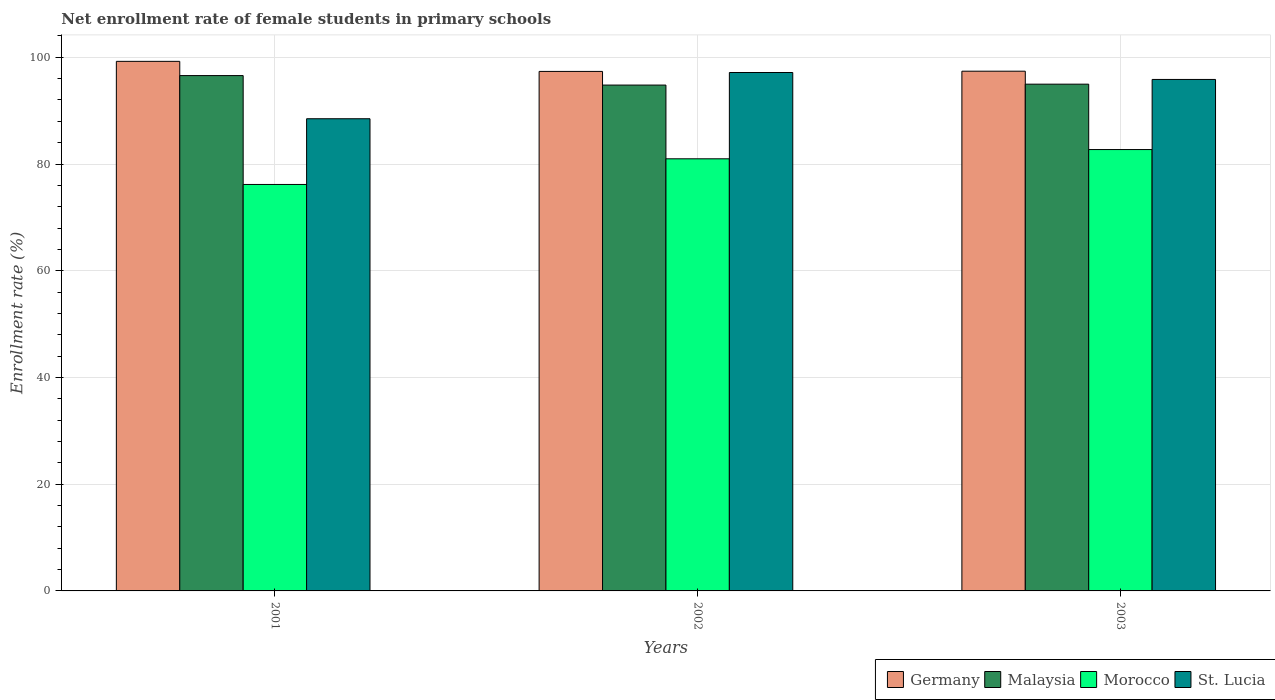How many different coloured bars are there?
Ensure brevity in your answer.  4. How many groups of bars are there?
Offer a very short reply. 3. Are the number of bars per tick equal to the number of legend labels?
Provide a succinct answer. Yes. Are the number of bars on each tick of the X-axis equal?
Your answer should be compact. Yes. What is the net enrollment rate of female students in primary schools in St. Lucia in 2003?
Your response must be concise. 95.85. Across all years, what is the maximum net enrollment rate of female students in primary schools in St. Lucia?
Provide a succinct answer. 97.15. Across all years, what is the minimum net enrollment rate of female students in primary schools in Malaysia?
Offer a terse response. 94.8. In which year was the net enrollment rate of female students in primary schools in Morocco maximum?
Your response must be concise. 2003. What is the total net enrollment rate of female students in primary schools in St. Lucia in the graph?
Offer a terse response. 281.49. What is the difference between the net enrollment rate of female students in primary schools in Malaysia in 2002 and that in 2003?
Offer a terse response. -0.17. What is the difference between the net enrollment rate of female students in primary schools in Germany in 2003 and the net enrollment rate of female students in primary schools in St. Lucia in 2001?
Offer a terse response. 8.91. What is the average net enrollment rate of female students in primary schools in Germany per year?
Offer a terse response. 98. In the year 2001, what is the difference between the net enrollment rate of female students in primary schools in Morocco and net enrollment rate of female students in primary schools in Malaysia?
Offer a very short reply. -20.4. In how many years, is the net enrollment rate of female students in primary schools in Morocco greater than 28 %?
Your answer should be very brief. 3. What is the ratio of the net enrollment rate of female students in primary schools in St. Lucia in 2002 to that in 2003?
Your response must be concise. 1.01. Is the difference between the net enrollment rate of female students in primary schools in Morocco in 2002 and 2003 greater than the difference between the net enrollment rate of female students in primary schools in Malaysia in 2002 and 2003?
Provide a succinct answer. No. What is the difference between the highest and the second highest net enrollment rate of female students in primary schools in Germany?
Offer a very short reply. 1.84. What is the difference between the highest and the lowest net enrollment rate of female students in primary schools in Germany?
Offer a terse response. 1.89. In how many years, is the net enrollment rate of female students in primary schools in Morocco greater than the average net enrollment rate of female students in primary schools in Morocco taken over all years?
Ensure brevity in your answer.  2. What does the 2nd bar from the left in 2003 represents?
Your response must be concise. Malaysia. What does the 2nd bar from the right in 2001 represents?
Keep it short and to the point. Morocco. Is it the case that in every year, the sum of the net enrollment rate of female students in primary schools in Malaysia and net enrollment rate of female students in primary schools in Germany is greater than the net enrollment rate of female students in primary schools in Morocco?
Provide a short and direct response. Yes. How many bars are there?
Offer a terse response. 12. Are all the bars in the graph horizontal?
Your answer should be very brief. No. Are the values on the major ticks of Y-axis written in scientific E-notation?
Offer a very short reply. No. Does the graph contain any zero values?
Ensure brevity in your answer.  No. Where does the legend appear in the graph?
Give a very brief answer. Bottom right. How many legend labels are there?
Offer a very short reply. 4. How are the legend labels stacked?
Give a very brief answer. Horizontal. What is the title of the graph?
Ensure brevity in your answer.  Net enrollment rate of female students in primary schools. What is the label or title of the Y-axis?
Your answer should be very brief. Enrollment rate (%). What is the Enrollment rate (%) in Germany in 2001?
Offer a terse response. 99.24. What is the Enrollment rate (%) of Malaysia in 2001?
Provide a succinct answer. 96.57. What is the Enrollment rate (%) in Morocco in 2001?
Ensure brevity in your answer.  76.17. What is the Enrollment rate (%) of St. Lucia in 2001?
Offer a terse response. 88.49. What is the Enrollment rate (%) in Germany in 2002?
Your answer should be compact. 97.36. What is the Enrollment rate (%) of Malaysia in 2002?
Your response must be concise. 94.8. What is the Enrollment rate (%) of Morocco in 2002?
Offer a very short reply. 80.98. What is the Enrollment rate (%) of St. Lucia in 2002?
Offer a very short reply. 97.15. What is the Enrollment rate (%) in Germany in 2003?
Give a very brief answer. 97.4. What is the Enrollment rate (%) of Malaysia in 2003?
Keep it short and to the point. 94.97. What is the Enrollment rate (%) of Morocco in 2003?
Offer a terse response. 82.71. What is the Enrollment rate (%) of St. Lucia in 2003?
Your response must be concise. 95.85. Across all years, what is the maximum Enrollment rate (%) in Germany?
Make the answer very short. 99.24. Across all years, what is the maximum Enrollment rate (%) of Malaysia?
Provide a short and direct response. 96.57. Across all years, what is the maximum Enrollment rate (%) in Morocco?
Ensure brevity in your answer.  82.71. Across all years, what is the maximum Enrollment rate (%) in St. Lucia?
Provide a succinct answer. 97.15. Across all years, what is the minimum Enrollment rate (%) in Germany?
Provide a succinct answer. 97.36. Across all years, what is the minimum Enrollment rate (%) of Malaysia?
Give a very brief answer. 94.8. Across all years, what is the minimum Enrollment rate (%) of Morocco?
Ensure brevity in your answer.  76.17. Across all years, what is the minimum Enrollment rate (%) of St. Lucia?
Your response must be concise. 88.49. What is the total Enrollment rate (%) of Germany in the graph?
Make the answer very short. 293.99. What is the total Enrollment rate (%) in Malaysia in the graph?
Your answer should be compact. 286.34. What is the total Enrollment rate (%) of Morocco in the graph?
Your answer should be compact. 239.86. What is the total Enrollment rate (%) of St. Lucia in the graph?
Your response must be concise. 281.49. What is the difference between the Enrollment rate (%) of Germany in 2001 and that in 2002?
Make the answer very short. 1.89. What is the difference between the Enrollment rate (%) of Malaysia in 2001 and that in 2002?
Make the answer very short. 1.78. What is the difference between the Enrollment rate (%) of Morocco in 2001 and that in 2002?
Your answer should be very brief. -4.81. What is the difference between the Enrollment rate (%) in St. Lucia in 2001 and that in 2002?
Your answer should be compact. -8.66. What is the difference between the Enrollment rate (%) in Germany in 2001 and that in 2003?
Ensure brevity in your answer.  1.84. What is the difference between the Enrollment rate (%) in Malaysia in 2001 and that in 2003?
Offer a very short reply. 1.61. What is the difference between the Enrollment rate (%) of Morocco in 2001 and that in 2003?
Offer a terse response. -6.54. What is the difference between the Enrollment rate (%) in St. Lucia in 2001 and that in 2003?
Offer a terse response. -7.36. What is the difference between the Enrollment rate (%) in Germany in 2002 and that in 2003?
Keep it short and to the point. -0.04. What is the difference between the Enrollment rate (%) of Malaysia in 2002 and that in 2003?
Offer a very short reply. -0.17. What is the difference between the Enrollment rate (%) of Morocco in 2002 and that in 2003?
Your answer should be very brief. -1.73. What is the difference between the Enrollment rate (%) of St. Lucia in 2002 and that in 2003?
Provide a short and direct response. 1.3. What is the difference between the Enrollment rate (%) in Germany in 2001 and the Enrollment rate (%) in Malaysia in 2002?
Offer a very short reply. 4.44. What is the difference between the Enrollment rate (%) in Germany in 2001 and the Enrollment rate (%) in Morocco in 2002?
Offer a very short reply. 18.26. What is the difference between the Enrollment rate (%) of Germany in 2001 and the Enrollment rate (%) of St. Lucia in 2002?
Provide a succinct answer. 2.09. What is the difference between the Enrollment rate (%) of Malaysia in 2001 and the Enrollment rate (%) of Morocco in 2002?
Your response must be concise. 15.6. What is the difference between the Enrollment rate (%) in Malaysia in 2001 and the Enrollment rate (%) in St. Lucia in 2002?
Give a very brief answer. -0.58. What is the difference between the Enrollment rate (%) in Morocco in 2001 and the Enrollment rate (%) in St. Lucia in 2002?
Your answer should be very brief. -20.98. What is the difference between the Enrollment rate (%) of Germany in 2001 and the Enrollment rate (%) of Malaysia in 2003?
Give a very brief answer. 4.28. What is the difference between the Enrollment rate (%) in Germany in 2001 and the Enrollment rate (%) in Morocco in 2003?
Offer a very short reply. 16.53. What is the difference between the Enrollment rate (%) in Germany in 2001 and the Enrollment rate (%) in St. Lucia in 2003?
Your answer should be compact. 3.39. What is the difference between the Enrollment rate (%) in Malaysia in 2001 and the Enrollment rate (%) in Morocco in 2003?
Give a very brief answer. 13.86. What is the difference between the Enrollment rate (%) of Malaysia in 2001 and the Enrollment rate (%) of St. Lucia in 2003?
Keep it short and to the point. 0.73. What is the difference between the Enrollment rate (%) in Morocco in 2001 and the Enrollment rate (%) in St. Lucia in 2003?
Your answer should be compact. -19.68. What is the difference between the Enrollment rate (%) of Germany in 2002 and the Enrollment rate (%) of Malaysia in 2003?
Give a very brief answer. 2.39. What is the difference between the Enrollment rate (%) of Germany in 2002 and the Enrollment rate (%) of Morocco in 2003?
Provide a succinct answer. 14.64. What is the difference between the Enrollment rate (%) of Germany in 2002 and the Enrollment rate (%) of St. Lucia in 2003?
Your response must be concise. 1.51. What is the difference between the Enrollment rate (%) of Malaysia in 2002 and the Enrollment rate (%) of Morocco in 2003?
Your answer should be compact. 12.09. What is the difference between the Enrollment rate (%) of Malaysia in 2002 and the Enrollment rate (%) of St. Lucia in 2003?
Give a very brief answer. -1.05. What is the difference between the Enrollment rate (%) of Morocco in 2002 and the Enrollment rate (%) of St. Lucia in 2003?
Your answer should be very brief. -14.87. What is the average Enrollment rate (%) in Germany per year?
Keep it short and to the point. 98. What is the average Enrollment rate (%) of Malaysia per year?
Provide a succinct answer. 95.45. What is the average Enrollment rate (%) in Morocco per year?
Offer a very short reply. 79.95. What is the average Enrollment rate (%) of St. Lucia per year?
Offer a very short reply. 93.83. In the year 2001, what is the difference between the Enrollment rate (%) in Germany and Enrollment rate (%) in Malaysia?
Offer a very short reply. 2.67. In the year 2001, what is the difference between the Enrollment rate (%) in Germany and Enrollment rate (%) in Morocco?
Provide a short and direct response. 23.07. In the year 2001, what is the difference between the Enrollment rate (%) in Germany and Enrollment rate (%) in St. Lucia?
Provide a succinct answer. 10.75. In the year 2001, what is the difference between the Enrollment rate (%) of Malaysia and Enrollment rate (%) of Morocco?
Your answer should be very brief. 20.4. In the year 2001, what is the difference between the Enrollment rate (%) of Malaysia and Enrollment rate (%) of St. Lucia?
Provide a succinct answer. 8.09. In the year 2001, what is the difference between the Enrollment rate (%) in Morocco and Enrollment rate (%) in St. Lucia?
Provide a succinct answer. -12.32. In the year 2002, what is the difference between the Enrollment rate (%) of Germany and Enrollment rate (%) of Malaysia?
Your answer should be very brief. 2.56. In the year 2002, what is the difference between the Enrollment rate (%) of Germany and Enrollment rate (%) of Morocco?
Provide a succinct answer. 16.38. In the year 2002, what is the difference between the Enrollment rate (%) in Germany and Enrollment rate (%) in St. Lucia?
Offer a terse response. 0.2. In the year 2002, what is the difference between the Enrollment rate (%) in Malaysia and Enrollment rate (%) in Morocco?
Your answer should be compact. 13.82. In the year 2002, what is the difference between the Enrollment rate (%) of Malaysia and Enrollment rate (%) of St. Lucia?
Give a very brief answer. -2.35. In the year 2002, what is the difference between the Enrollment rate (%) in Morocco and Enrollment rate (%) in St. Lucia?
Provide a short and direct response. -16.17. In the year 2003, what is the difference between the Enrollment rate (%) in Germany and Enrollment rate (%) in Malaysia?
Offer a terse response. 2.43. In the year 2003, what is the difference between the Enrollment rate (%) in Germany and Enrollment rate (%) in Morocco?
Keep it short and to the point. 14.69. In the year 2003, what is the difference between the Enrollment rate (%) in Germany and Enrollment rate (%) in St. Lucia?
Provide a succinct answer. 1.55. In the year 2003, what is the difference between the Enrollment rate (%) of Malaysia and Enrollment rate (%) of Morocco?
Make the answer very short. 12.25. In the year 2003, what is the difference between the Enrollment rate (%) in Malaysia and Enrollment rate (%) in St. Lucia?
Make the answer very short. -0.88. In the year 2003, what is the difference between the Enrollment rate (%) of Morocco and Enrollment rate (%) of St. Lucia?
Make the answer very short. -13.14. What is the ratio of the Enrollment rate (%) in Germany in 2001 to that in 2002?
Your answer should be compact. 1.02. What is the ratio of the Enrollment rate (%) of Malaysia in 2001 to that in 2002?
Provide a short and direct response. 1.02. What is the ratio of the Enrollment rate (%) in Morocco in 2001 to that in 2002?
Your answer should be compact. 0.94. What is the ratio of the Enrollment rate (%) of St. Lucia in 2001 to that in 2002?
Provide a short and direct response. 0.91. What is the ratio of the Enrollment rate (%) in Germany in 2001 to that in 2003?
Make the answer very short. 1.02. What is the ratio of the Enrollment rate (%) of Malaysia in 2001 to that in 2003?
Offer a very short reply. 1.02. What is the ratio of the Enrollment rate (%) in Morocco in 2001 to that in 2003?
Your answer should be compact. 0.92. What is the ratio of the Enrollment rate (%) in St. Lucia in 2001 to that in 2003?
Provide a succinct answer. 0.92. What is the ratio of the Enrollment rate (%) of Germany in 2002 to that in 2003?
Offer a terse response. 1. What is the ratio of the Enrollment rate (%) of Malaysia in 2002 to that in 2003?
Your answer should be very brief. 1. What is the ratio of the Enrollment rate (%) of Morocco in 2002 to that in 2003?
Your answer should be very brief. 0.98. What is the ratio of the Enrollment rate (%) in St. Lucia in 2002 to that in 2003?
Give a very brief answer. 1.01. What is the difference between the highest and the second highest Enrollment rate (%) in Germany?
Offer a very short reply. 1.84. What is the difference between the highest and the second highest Enrollment rate (%) of Malaysia?
Offer a very short reply. 1.61. What is the difference between the highest and the second highest Enrollment rate (%) of Morocco?
Provide a succinct answer. 1.73. What is the difference between the highest and the second highest Enrollment rate (%) of St. Lucia?
Keep it short and to the point. 1.3. What is the difference between the highest and the lowest Enrollment rate (%) in Germany?
Keep it short and to the point. 1.89. What is the difference between the highest and the lowest Enrollment rate (%) in Malaysia?
Make the answer very short. 1.78. What is the difference between the highest and the lowest Enrollment rate (%) of Morocco?
Offer a very short reply. 6.54. What is the difference between the highest and the lowest Enrollment rate (%) of St. Lucia?
Your answer should be compact. 8.66. 